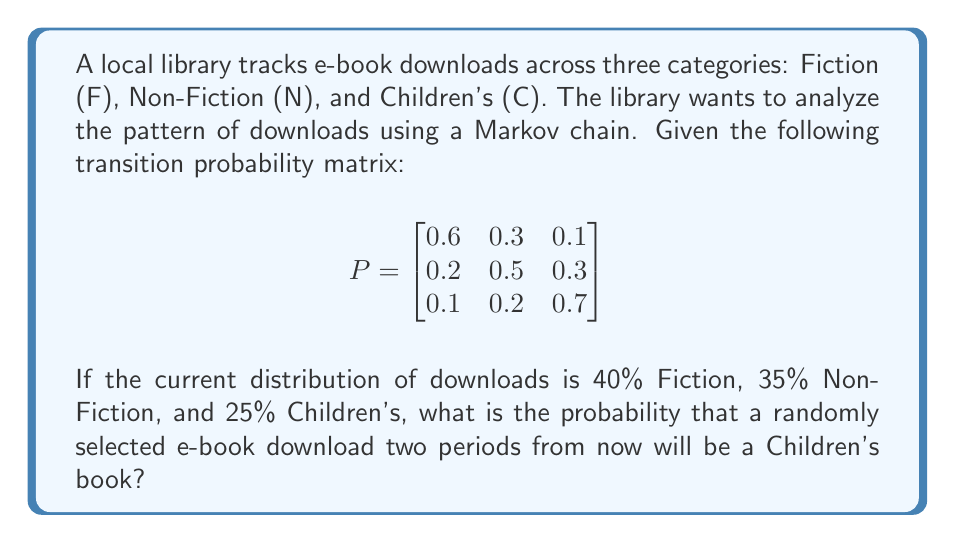Teach me how to tackle this problem. Let's approach this step-by-step:

1) First, we need to represent the current distribution as a row vector:
   $$\pi_0 = [0.4 \quad 0.35 \quad 0.25]$$

2) To find the distribution after two periods, we need to multiply this vector by the transition matrix twice:
   $$\pi_2 = \pi_0 P^2$$

3) Let's calculate $P^2$:
   $$P^2 = P \times P = \begin{bmatrix}
   0.6 & 0.3 & 0.1 \\
   0.2 & 0.5 & 0.3 \\
   0.1 & 0.2 & 0.7
   \end{bmatrix} \times \begin{bmatrix}
   0.6 & 0.3 & 0.1 \\
   0.2 & 0.5 & 0.3 \\
   0.1 & 0.2 & 0.7
   \end{bmatrix}$$

4) Multiplying these matrices:
   $$P^2 = \begin{bmatrix}
   0.41 & 0.33 & 0.26 \\
   0.25 & 0.38 & 0.37 \\
   0.16 & 0.26 & 0.58
   \end{bmatrix}$$

5) Now, we can calculate $\pi_2$:
   $$\pi_2 = [0.4 \quad 0.35 \quad 0.25] \times \begin{bmatrix}
   0.41 & 0.33 & 0.26 \\
   0.25 & 0.38 & 0.37 \\
   0.16 & 0.26 & 0.58
   \end{bmatrix}$$

6) Multiplying:
   $$\pi_2 = [0.3025 \quad 0.3305 \quad 0.3670]$$

7) The probability of a Children's book download two periods from now is the third element of this vector: 0.3670 or 36.70%.
Answer: 0.3670 (or 36.70%) 